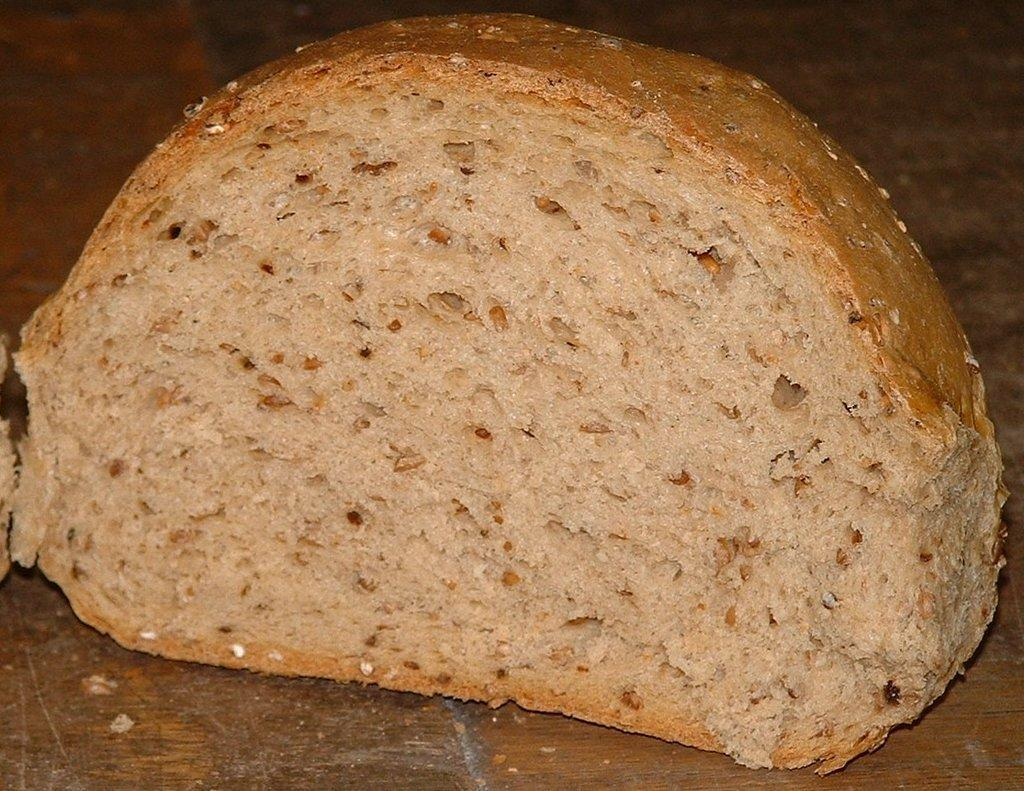What type of bread is visible in the image? There is a sourdough bread in the image. Where might the bread be located in the image? The bread might be placed on a table. What is the color of the background in the image? The background of the image is brown in color. How is the background of the image depicted? The image is blurred in the background. What type of card can be seen hanging from the icicle in the image? There is no card or icicle present in the image; it features a sourdough bread and a blurred brown background. How many chickens are visible in the image? There are no chickens present in the image. 